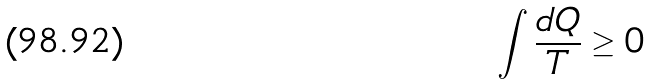<formula> <loc_0><loc_0><loc_500><loc_500>\int \frac { d Q } { T } \geq 0</formula> 